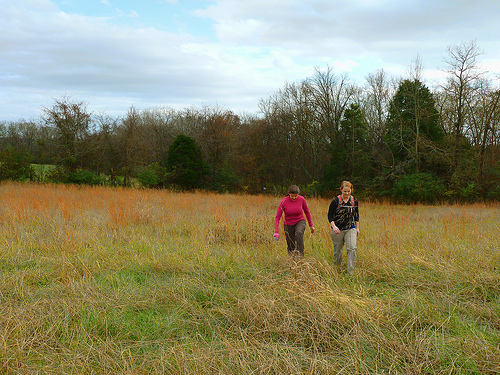<image>
Is there a field under the woman? Yes. The field is positioned underneath the woman, with the woman above it in the vertical space. Is there a woman behind the woman? No. The woman is not behind the woman. From this viewpoint, the woman appears to be positioned elsewhere in the scene. 